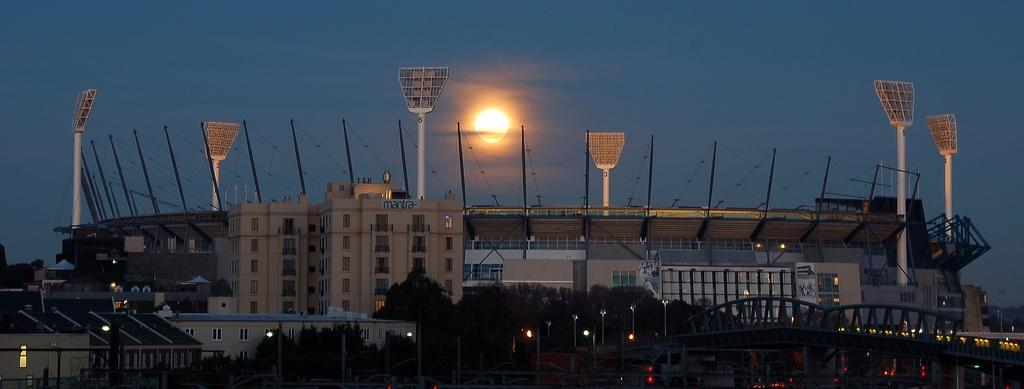What type of structures can be seen in the image? There are houses, a bridge, and a stadium in the image. What natural elements are present in the image? There are trees in the image. What man-made objects can be seen in the image? There are poles and lights in the image. What celestial body is visible in the background of the image? The sun is visible in the sky in the background of the image. What type of fork is being used by the committee in the image? There is no fork or committee present in the image. How many arrows are in the quiver in the image? There is no quiver or arrows present in the image. 